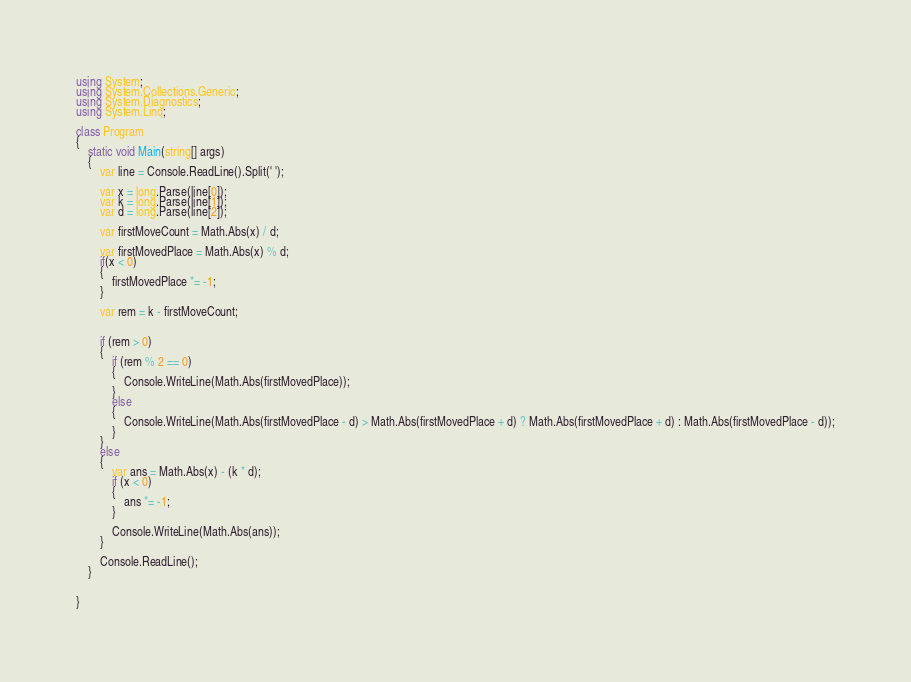Convert code to text. <code><loc_0><loc_0><loc_500><loc_500><_C#_>using System;
using System.Collections.Generic;
using System.Diagnostics;
using System.Linq;

class Program
{
    static void Main(string[] args)
    {
        var line = Console.ReadLine().Split(' ');

        var x = long.Parse(line[0]);
        var k = long.Parse(line[1]);
        var d = long.Parse(line[2]);

        var firstMoveCount = Math.Abs(x) / d;

        var firstMovedPlace = Math.Abs(x) % d;
        if(x < 0)
        {
            firstMovedPlace *= -1;
        }

        var rem = k - firstMoveCount;


        if (rem > 0)
        {
            if (rem % 2 == 0)
            {
                Console.WriteLine(Math.Abs(firstMovedPlace));
            }
            else
            {
                Console.WriteLine(Math.Abs(firstMovedPlace - d) > Math.Abs(firstMovedPlace + d) ? Math.Abs(firstMovedPlace + d) : Math.Abs(firstMovedPlace - d));
            }
        }
        else
        {
            var ans = Math.Abs(x) - (k * d);
            if (x < 0)
            {
                ans *= -1;
            }

            Console.WriteLine(Math.Abs(ans));
        }

        Console.ReadLine();
    }


}
</code> 